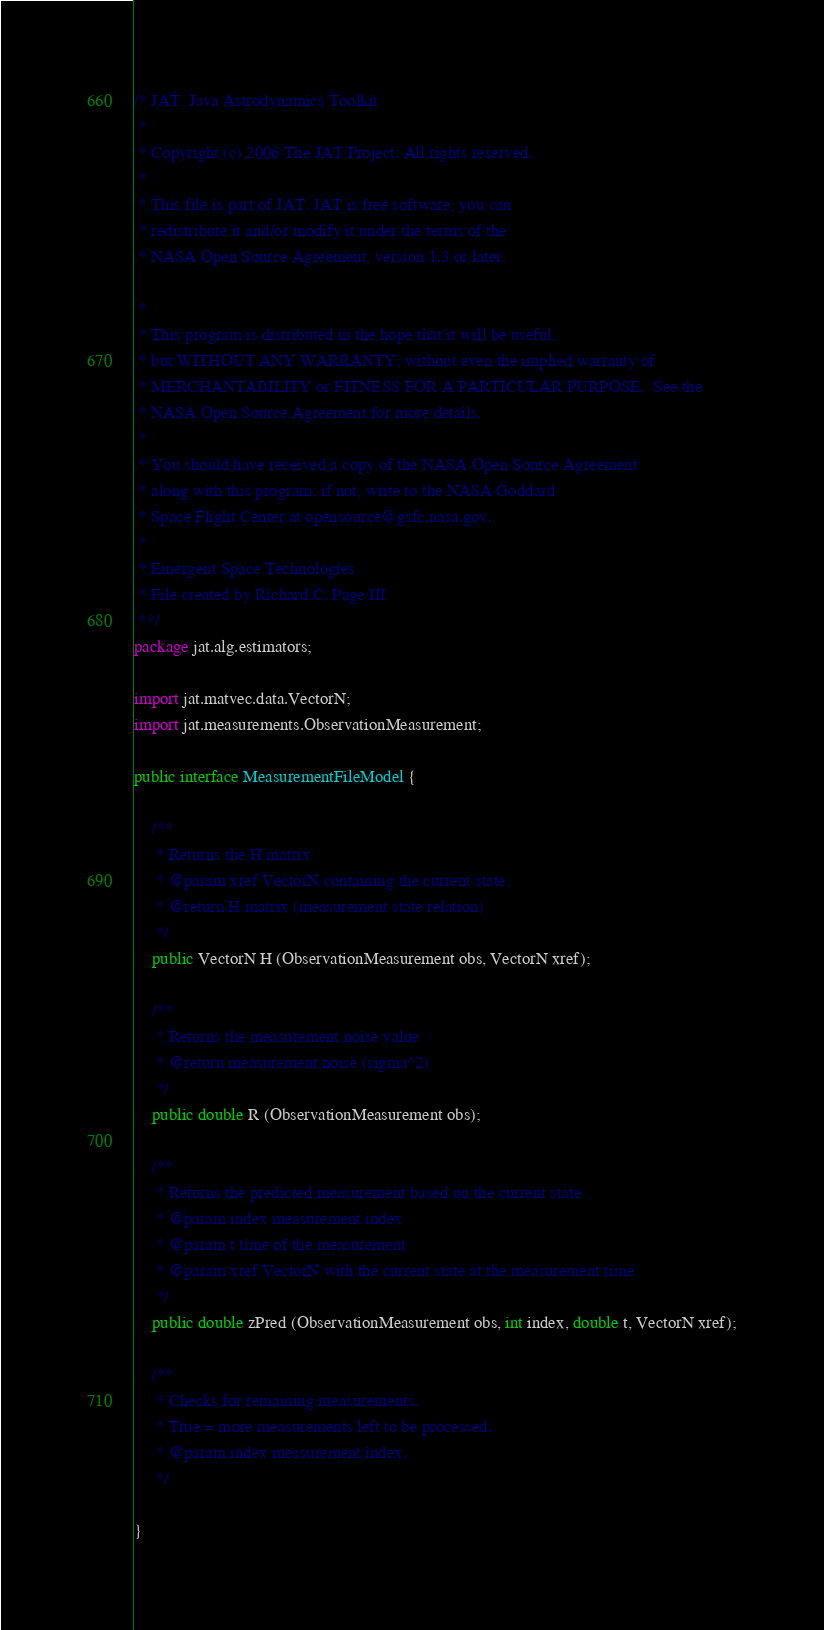Convert code to text. <code><loc_0><loc_0><loc_500><loc_500><_Java_>/* JAT: Java Astrodynamics Toolkit
 *
 * Copyright (c) 2006 The JAT Project. All rights reserved.
 *
 * This file is part of JAT. JAT is free software; you can 
 * redistribute it and/or modify it under the terms of the 
 * NASA Open Source Agreement, version 1.3 or later. 
 
 *
 * This program is distributed in the hope that it will be useful,
 * but WITHOUT ANY WARRANTY; without even the implied warranty of
 * MERCHANTABILITY or FITNESS FOR A PARTICULAR PURPOSE.  See the
 * NASA Open Source Agreement for more details.
 *
 * You should have received a copy of the NASA Open Source Agreement
 * along with this program; if not, write to the NASA Goddard
 * Space Flight Center at opensource@gsfc.nasa.gov.
 *
 * Emergent Space Technologies
 * File created by Richard C. Page III 
 **/
package jat.alg.estimators;

import jat.matvec.data.VectorN;
import jat.measurements.ObservationMeasurement;

public interface MeasurementFileModel {

	/**
	 * Returns the H matrix
	 * @param xref VectorN containing the current state
	 * @return H matrix (measurement state relation)
	 */
	public VectorN H (ObservationMeasurement obs, VectorN xref);

	/**
	 * Returns the measurement noise value
	 * @return measurement noise (sigma^2)
	 */
	public double R (ObservationMeasurement obs);

	/**
	 * Returns the predicted measurement based on the current state
	 * @param index measurement index
	 * @param t time of the measurement
	 * @param xref VectorN with the current state at the measurement time
	 */
	public double zPred (ObservationMeasurement obs, int index, double t, VectorN xref);

	/**
	 * Checks for remaining measurements. 
	 * True = more measurements left to be processed.
	 * @param index measurement index.
	 */

}
</code> 